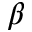<formula> <loc_0><loc_0><loc_500><loc_500>\beta</formula> 